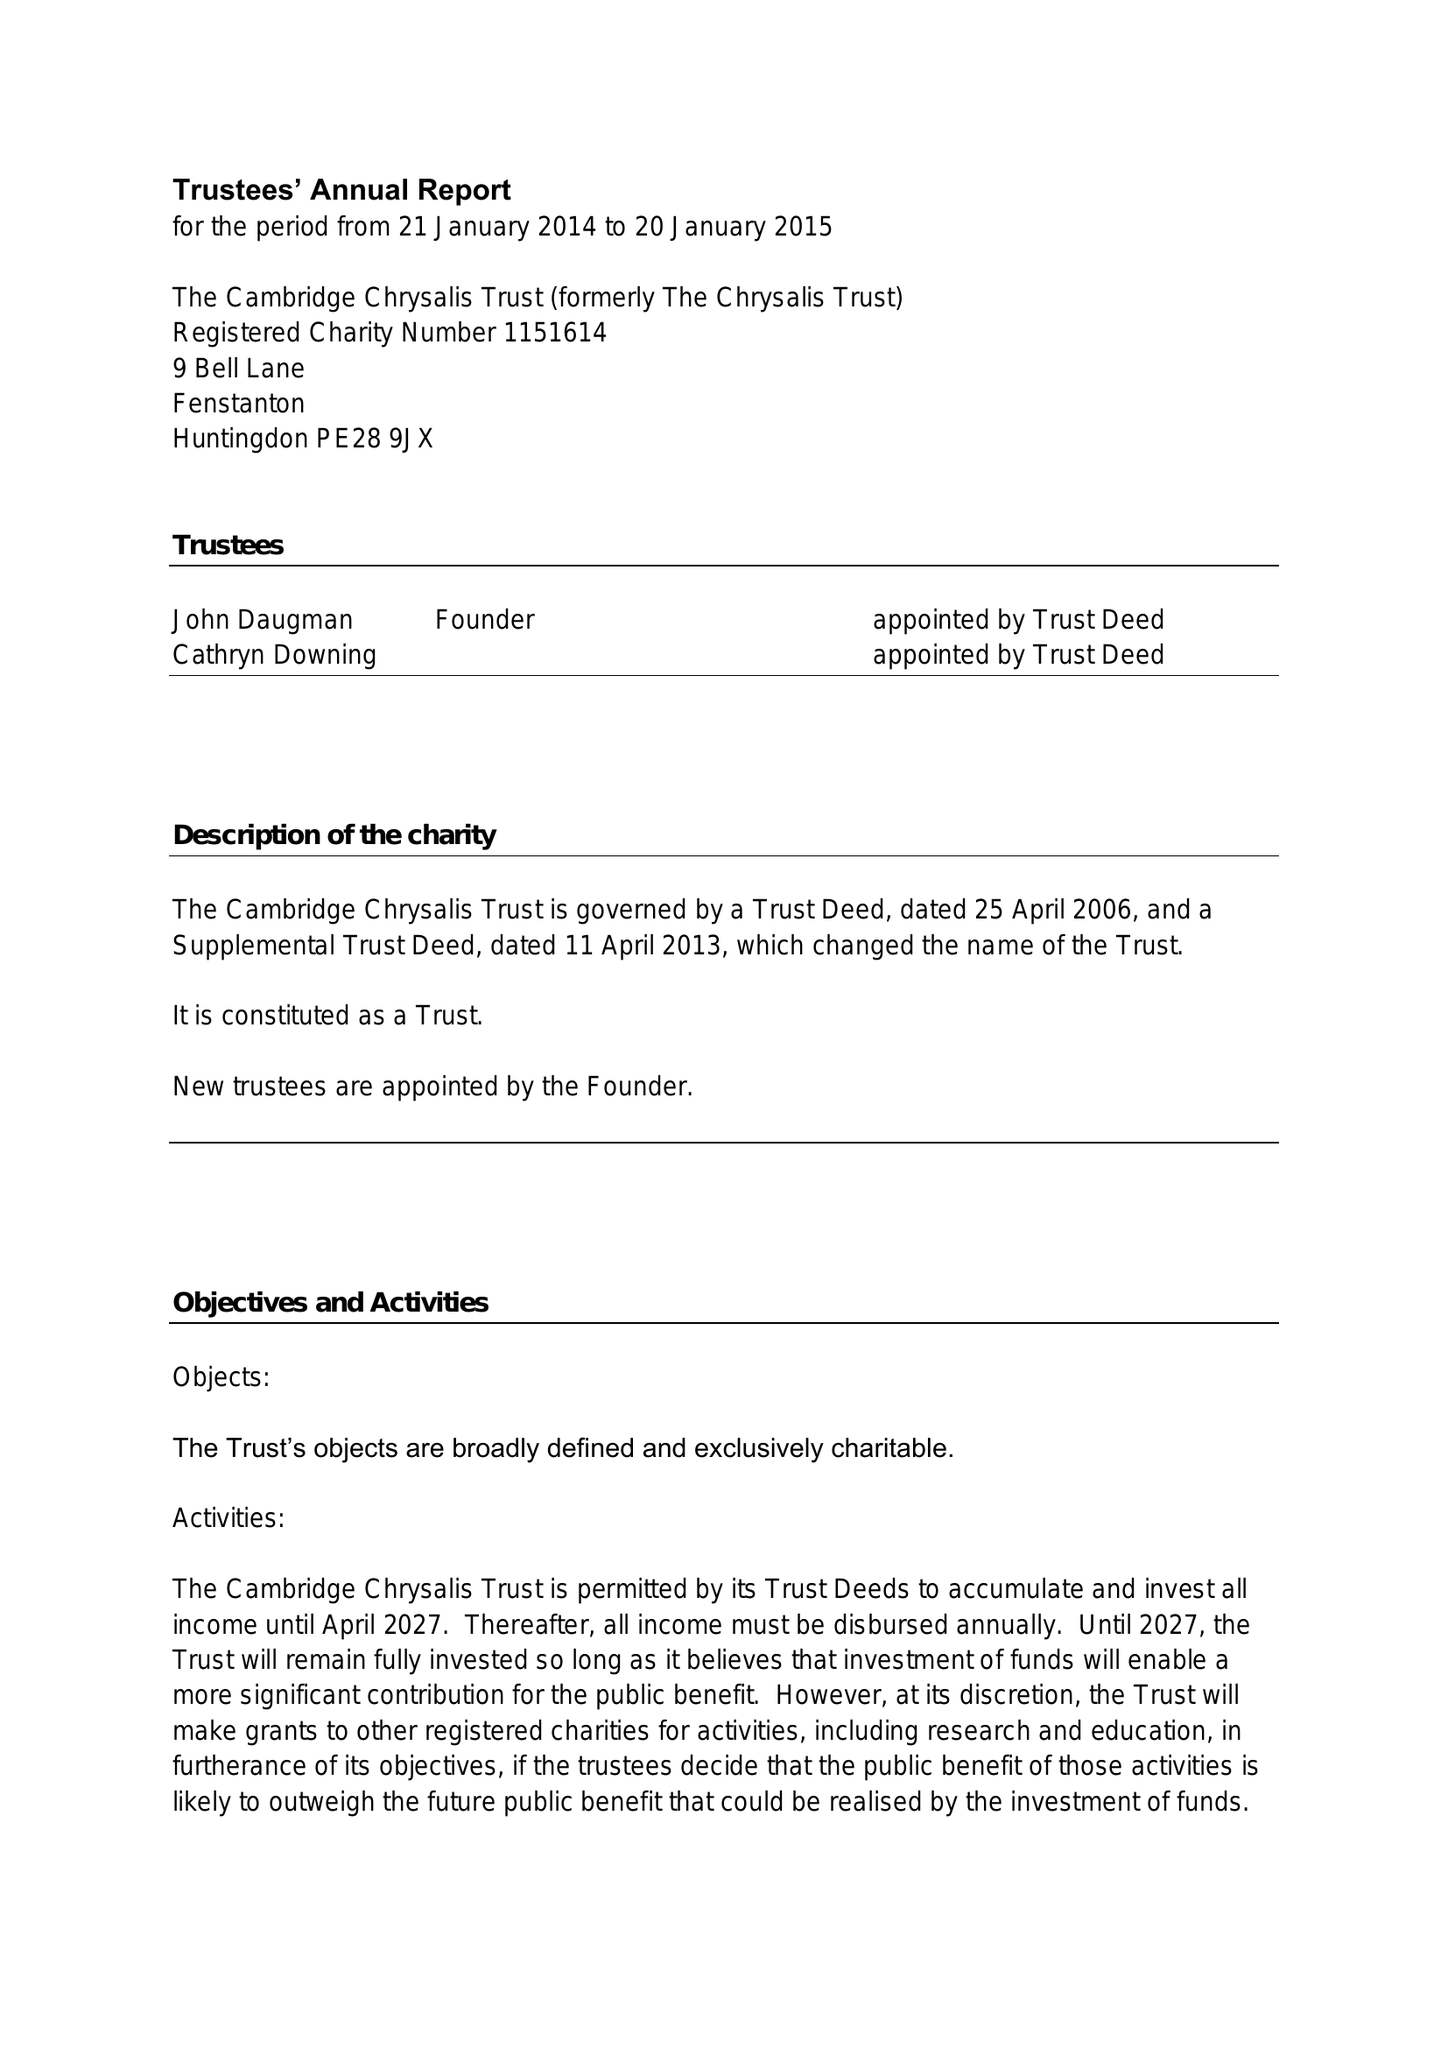What is the value for the address__street_line?
Answer the question using a single word or phrase. 9 BELL LANE 